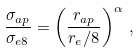<formula> <loc_0><loc_0><loc_500><loc_500>\frac { \sigma _ { a p } } { \sigma _ { e 8 } } = \left ( \frac { r _ { a p } } { r _ { e } / 8 } \right ) ^ { \alpha } \, ,</formula> 